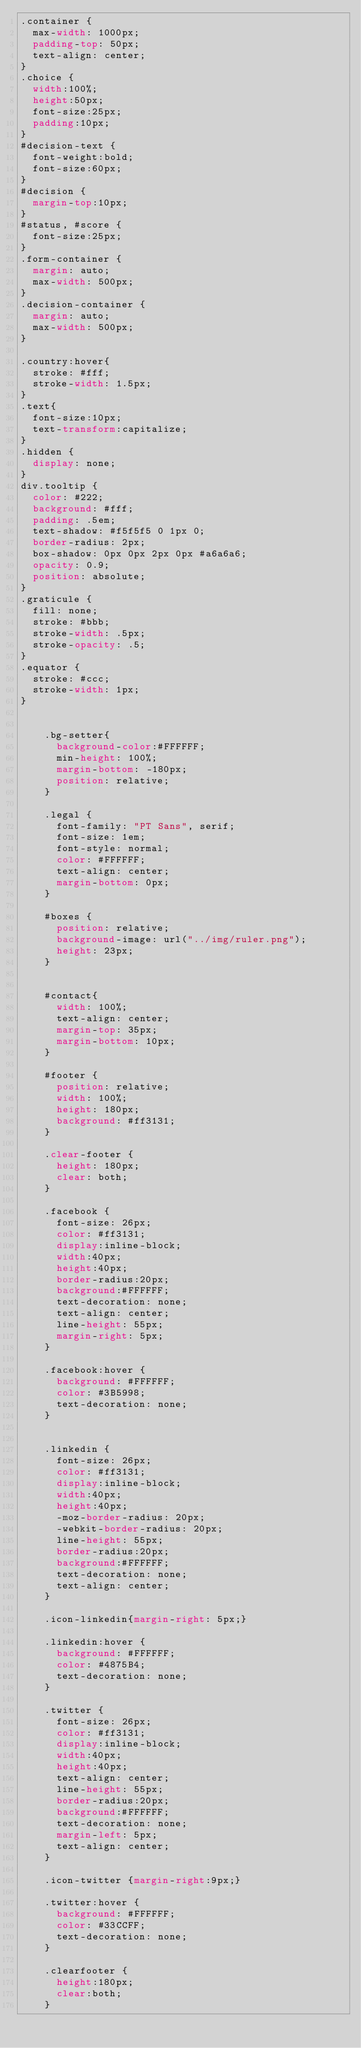Convert code to text. <code><loc_0><loc_0><loc_500><loc_500><_CSS_>.container {
  max-width: 1000px;
  padding-top: 50px;
  text-align: center;
}
.choice {
  width:100%;
  height:50px;
  font-size:25px;
  padding:10px;
}
#decision-text {
  font-weight:bold;
  font-size:60px;
}
#decision {
  margin-top:10px;
}
#status, #score {
  font-size:25px;
}
.form-container {
  margin: auto;
  max-width: 500px;
}
.decision-container {
  margin: auto;
  max-width: 500px;
}

.country:hover{
  stroke: #fff;
  stroke-width: 1.5px;
}
.text{
  font-size:10px;
  text-transform:capitalize;
}
.hidden { 
  display: none; 
}
div.tooltip {
  color: #222; 
  background: #fff; 
  padding: .5em; 
  text-shadow: #f5f5f5 0 1px 0;
  border-radius: 2px; 
  box-shadow: 0px 0px 2px 0px #a6a6a6; 
  opacity: 0.9; 
  position: absolute;
}
.graticule {
  fill: none;
  stroke: #bbb;
  stroke-width: .5px;
  stroke-opacity: .5;
}
.equator {
  stroke: #ccc;
  stroke-width: 1px;
}


		.bg-setter{
			background-color:#FFFFFF;
			min-height: 100%;
			margin-bottom: -180px;
			position: relative;
		}
		
		.legal {
			font-family: "PT Sans", serif;
			font-size: 1em;
			font-style: normal;
			color: #FFFFFF;
			text-align: center;
			margin-bottom: 0px;
		}
		
		#boxes {
			position: relative;
			background-image: url("../img/ruler.png");
			height: 23px;
		}

		
		#contact{
			width: 100%;
			text-align: center;
			margin-top: 35px;
			margin-bottom: 10px;
		}
		
		#footer {
			position: relative;
			width: 100%;
			height: 180px;
			background: #ff3131;
		}

		.clear-footer {
			height: 180px;
			clear: both;
		}
		
		.facebook {
			font-size: 26px;
			color: #ff3131;
			display:inline-block;
			width:40px;
			height:40px;
			border-radius:20px;
			background:#FFFFFF;
			text-decoration: none;
			text-align: center;
			line-height: 55px;
			margin-right: 5px;
		}

		.facebook:hover {
			background: #FFFFFF;
			color: #3B5998;
			text-decoration: none;
		}

		
		.linkedin {
			font-size: 26px;
			color: #ff3131;
			display:inline-block;
			width:40px;
			height:40px;
			-moz-border-radius: 20px;
			-webkit-border-radius: 20px;
			line-height: 55px;
			border-radius:20px;
			background:#FFFFFF;
			text-decoration: none;
			text-align: center;
		}

		.icon-linkedin{margin-right: 5px;}

		.linkedin:hover {
			background: #FFFFFF;
			color: #4875B4;
			text-decoration: none;
		}

		.twitter {
			font-size: 26px;
			color: #ff3131;
			display:inline-block;
			width:40px;
			height:40px;
			text-align: center;
			line-height: 55px;
			border-radius:20px;
			background:#FFFFFF;
			text-decoration: none;
			margin-left: 5px;
			text-align: center;
		}
		
		.icon-twitter {margin-right:9px;}

		.twitter:hover {
			background: #FFFFFF;
			color: #33CCFF;
			text-decoration: none;
		}
		
		.clearfooter {
			height:180px;
			clear:both;
		}
</code> 